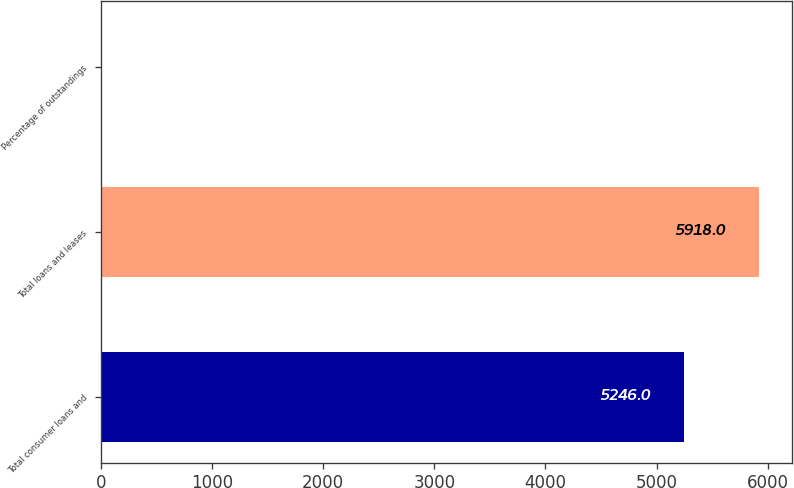<chart> <loc_0><loc_0><loc_500><loc_500><bar_chart><fcel>Total consumer loans and<fcel>Total loans and leases<fcel>Percentage of outstandings<nl><fcel>5246<fcel>5918<fcel>0.67<nl></chart> 